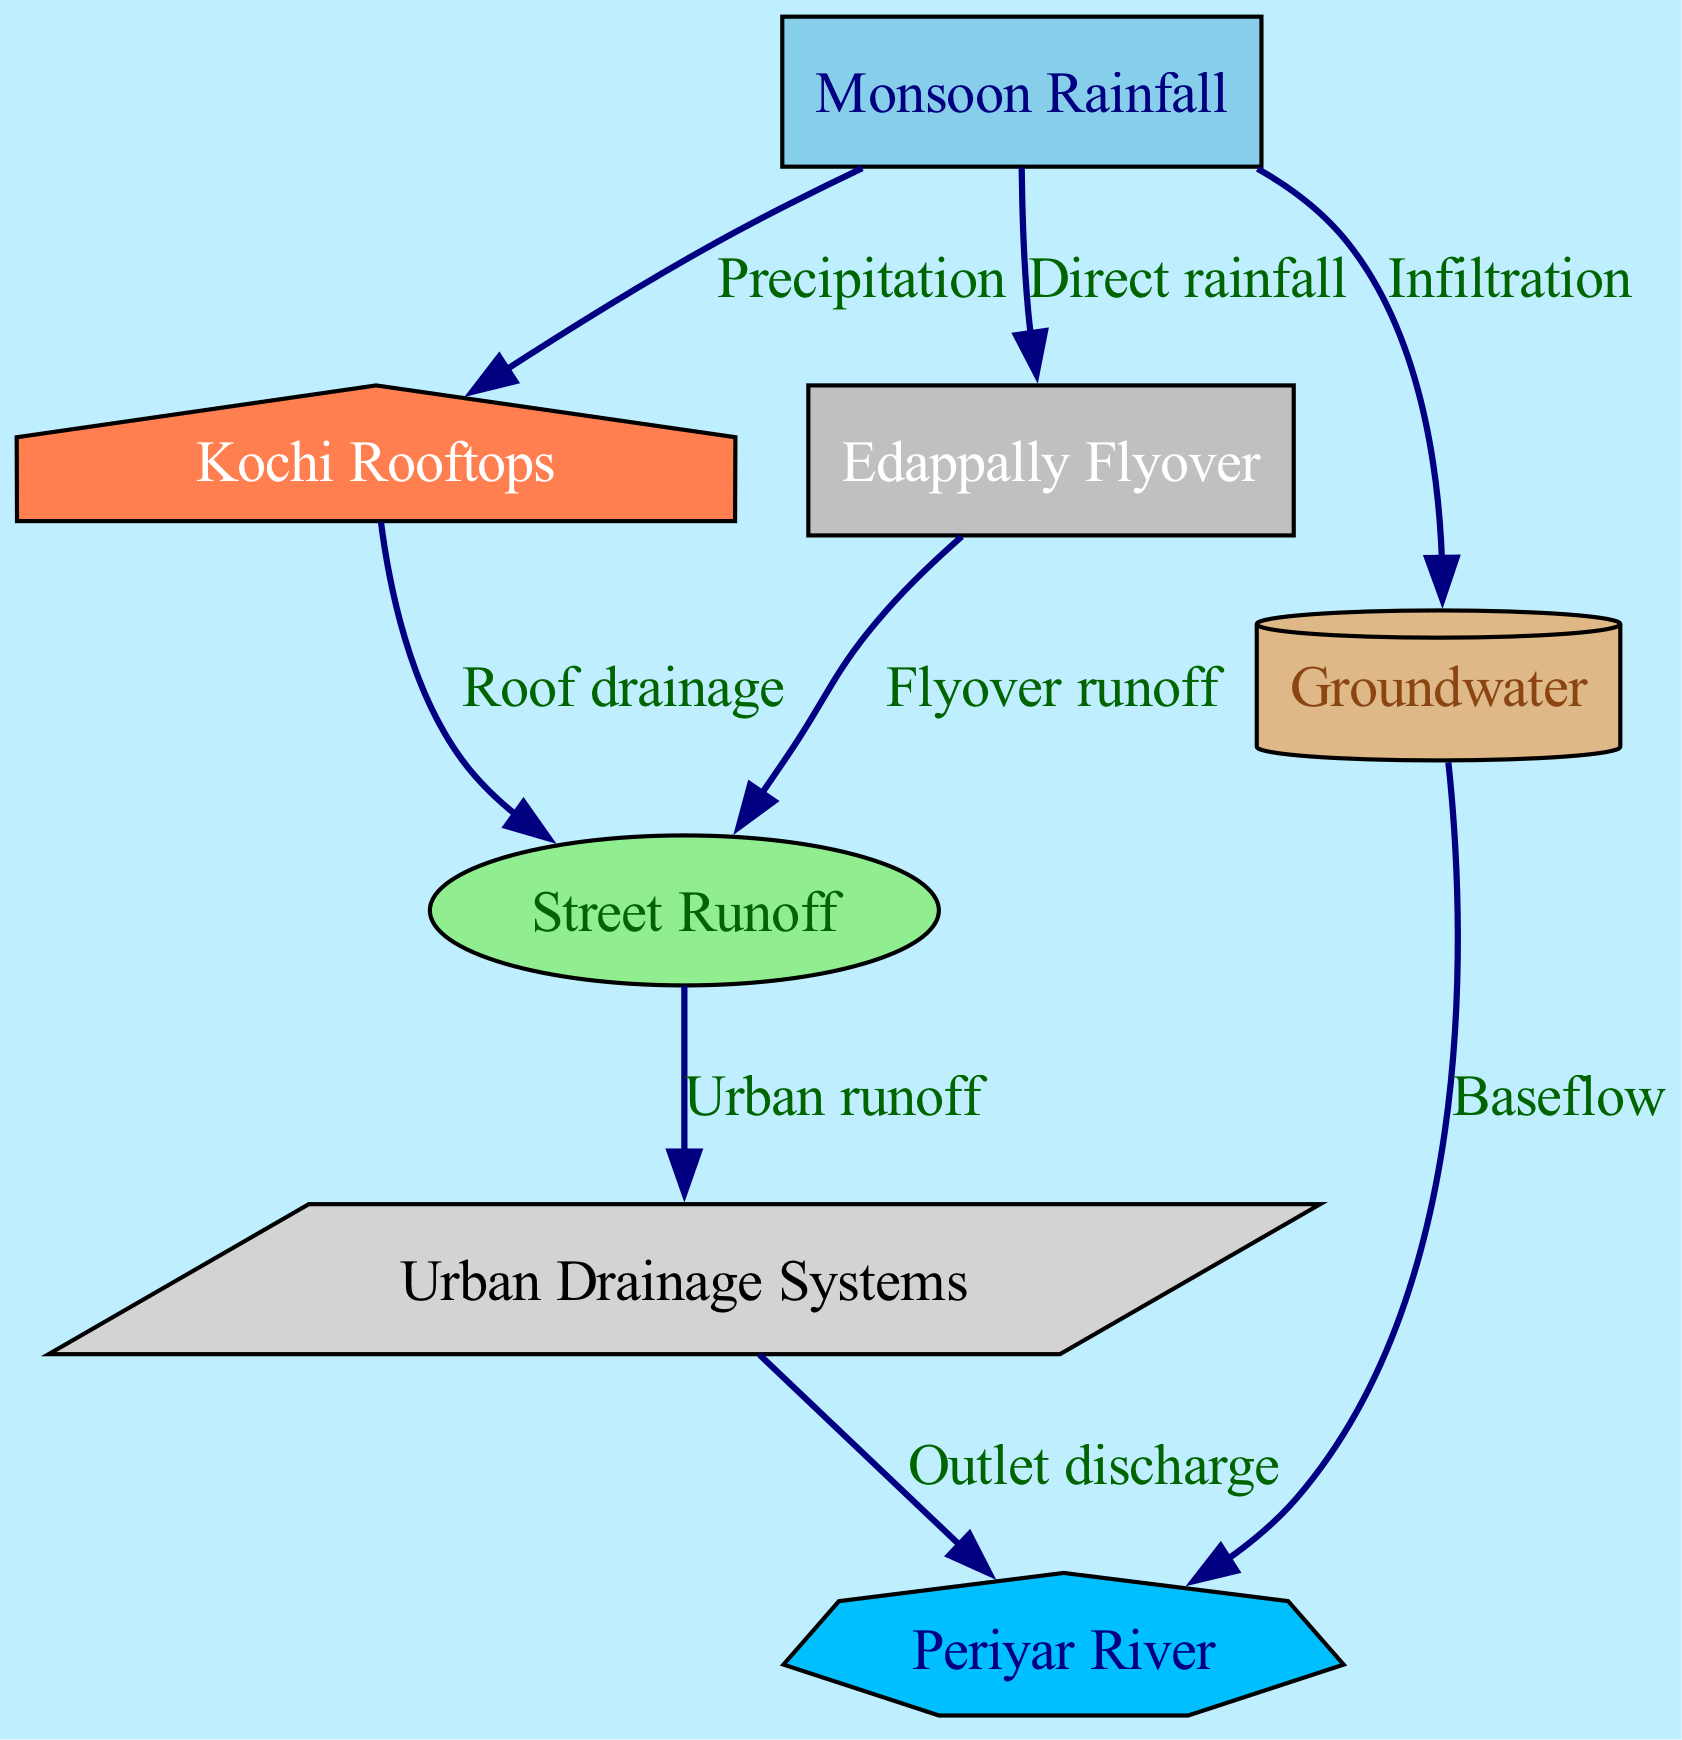What is the primary source of the water cycle in Kochi? The diagram indicates that "Monsoon Rainfall" is the primary source, represented as the starting node with direct precipitation to other elements.
Answer: Monsoon Rainfall How many nodes are present in the diagram? By counting the nodes listed in the data, we see there are 7 nodes representing different components of the water cycle.
Answer: 7 What type of runoff is associated with rooftops in Kochi? The diagram shows that "Kochi Rooftops" lead to "Street Runoff" through "Roof drainage," indicating that rooftop runoff directly contributes to street runoff.
Answer: Roof drainage What is the outcome of street runoff in relation to drainage systems? The edge between "Street Runoff" and "Urban Drainage Systems" indicates that street runoff is channeled into drainage systems, depicted in the diagram.
Answer: Urban runoff Which node indirectly receives water from rainfall through infiltration? The "Groundwater" node receives water from "Monsoon Rainfall" through the process of infiltration, as shown in the diagram's connections.
Answer: Groundwater What connection does groundwater have with the Periyar River? The diagram indicates that groundwater contributes to the Periyar River through "Baseflow," which suggests that groundwater feeds into the river.
Answer: Baseflow How does the Edappally flyover contribute to the water cycle? The diagram shows that the "Edappally Flyover" directs water to "Street Runoff," emphasizing its role in collecting and channeling rainwater.
Answer: Flyover runoff Which system is responsible for discharging water to the Periyar River? According to the diagram, "Urban Drainage Systems" are responsible for discharging water out to the Periyar River, depicted as the final connection in the flow.
Answer: Outlet discharge 